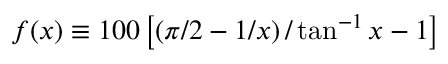<formula> <loc_0><loc_0><loc_500><loc_500>f ( x ) \equiv 1 0 0 \left [ \left ( \pi / 2 - 1 / x \right ) / \tan ^ { - 1 } x - 1 \right ]</formula> 